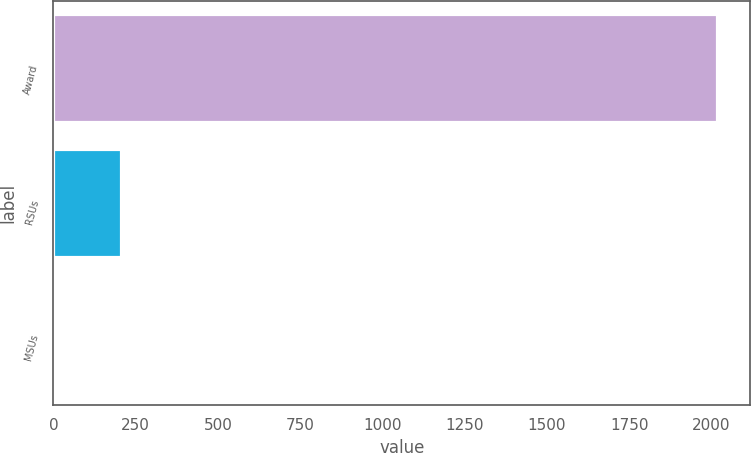<chart> <loc_0><loc_0><loc_500><loc_500><bar_chart><fcel>Award<fcel>RSUs<fcel>MSUs<nl><fcel>2017<fcel>205.3<fcel>4<nl></chart> 